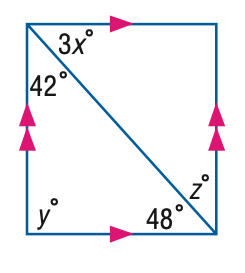Answer the mathemtical geometry problem and directly provide the correct option letter.
Question: Find x in the figure.
Choices: A: 12 B: 14 C: 16 D: 18 C 